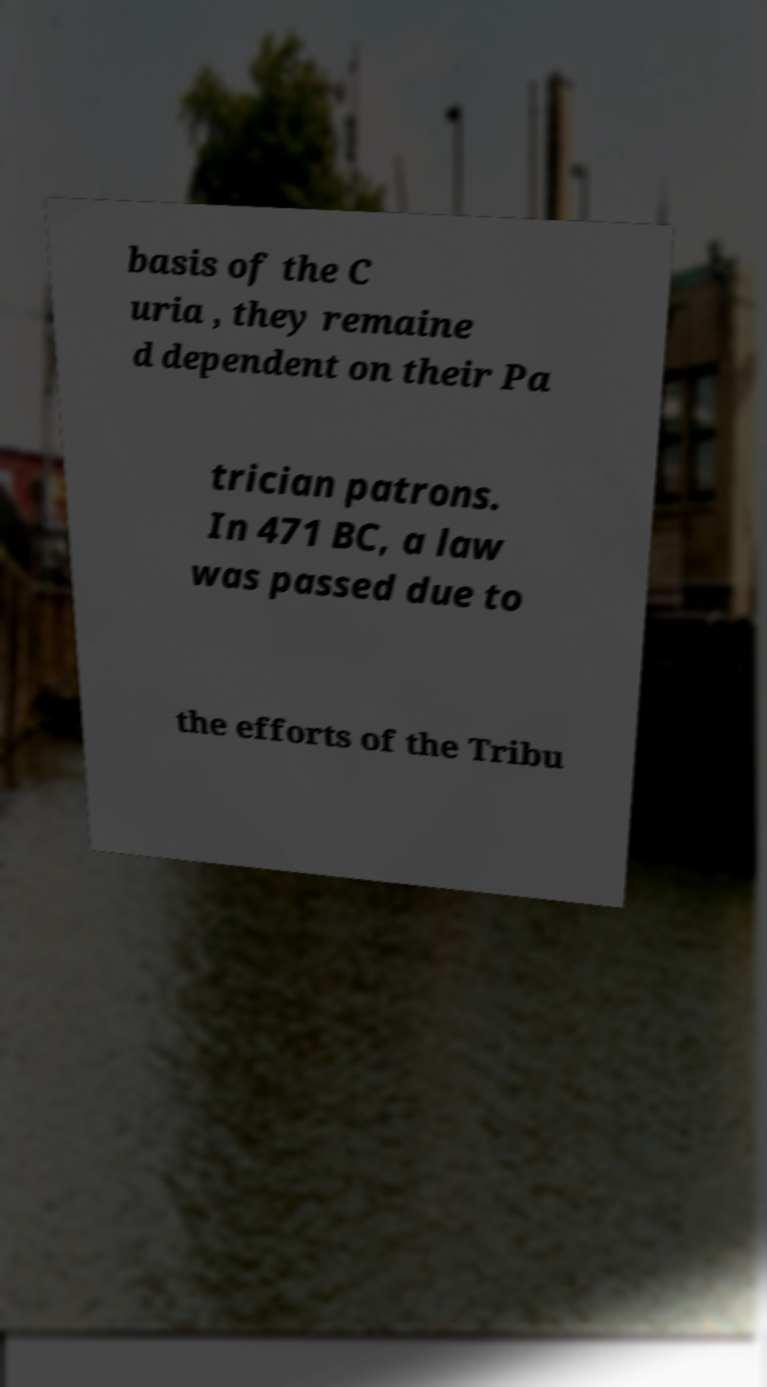For documentation purposes, I need the text within this image transcribed. Could you provide that? basis of the C uria , they remaine d dependent on their Pa trician patrons. In 471 BC, a law was passed due to the efforts of the Tribu 